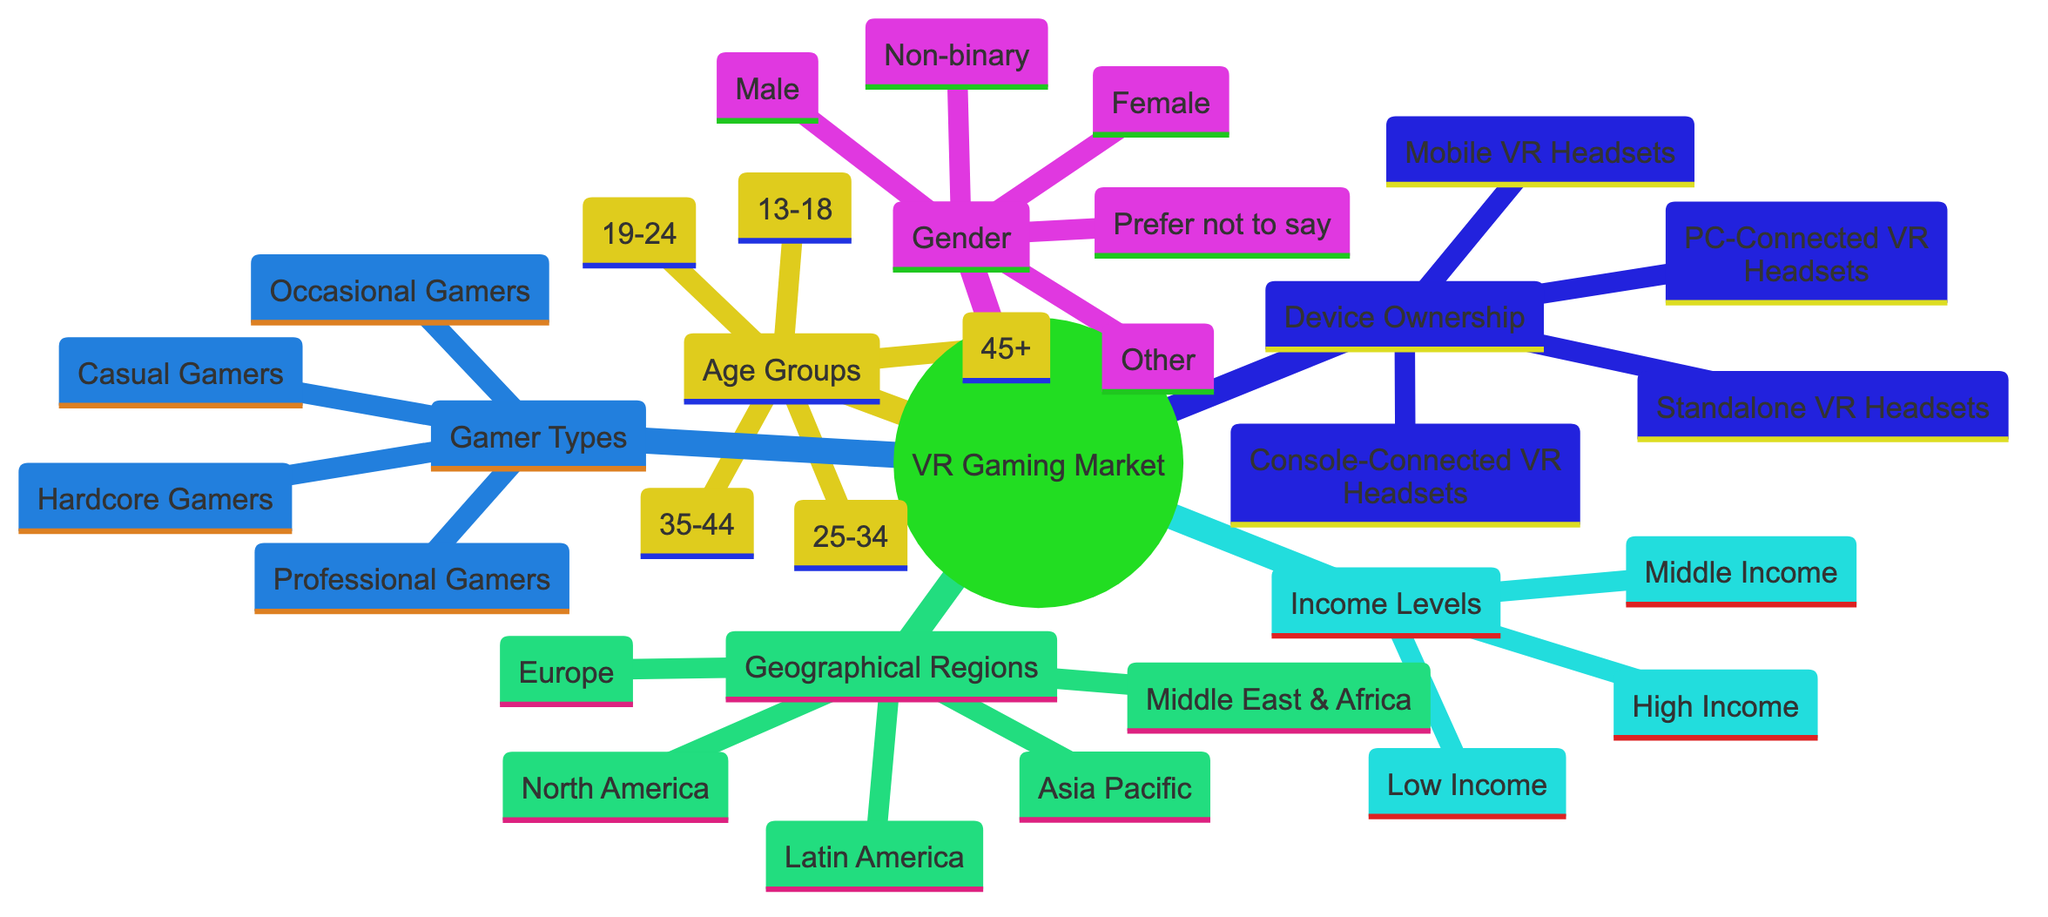What are the age ranges listed in the diagram? The diagram provides five age ranges: 13-18, 19-24, 25-34, 35-44, and 45+. They are listed under the node "Age Groups."
Answer: 13-18, 19-24, 25-34, 35-44, 45+ How many gender categories are represented in the diagram? Under the "Gender" node, there are five categories: Male, Female, Non-binary, Other, and Prefer not to say. This totals to five categories.
Answer: 5 Which geographical region is listed first in the diagram? The first geographical region mentioned under "Geographical Regions" is North America. It is positioned at the top of that section.
Answer: North America What is the income level category with the highest economic disposition? The diagram categorizes income levels and lists High Income as the category with the highest economic disposition among Low Income, Middle Income, and High Income.
Answer: High Income Which gamer type might represent players who play less frequently than hardcore gamers? Among the listed gamer types, Occasional Gamers are likely to be the players who play less frequently than Hardcore Gamers, as the name suggests.
Answer: Occasional Gamers What is the total number of device ownership types listed? The "Device Ownership" category includes four types of VR headsets: Standalone VR Headsets, PC-Connected VR Headsets, Console-Connected VR Headsets, and Mobile VR Headsets, totaling four types.
Answer: 4 Which geographical region is associated with the largest number of potential VR gamers? Although not explicitly stated in the diagram, North America is commonly associated with being a primary market for VR gaming based on trends and market research, making it the largest region.
Answer: North America What relationship can be inferred between income levels and device ownership? Generally, high-income individuals may be more capable of affording advanced VR devices, such as PC-Connected VR Headsets or Console-Connected VR Headsets, compared to those in lower income categories. The diagram suggests a link between income and higher-end VR device ownership.
Answer: Economic capacity influences device ownership 